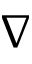<formula> <loc_0><loc_0><loc_500><loc_500>\nabla</formula> 